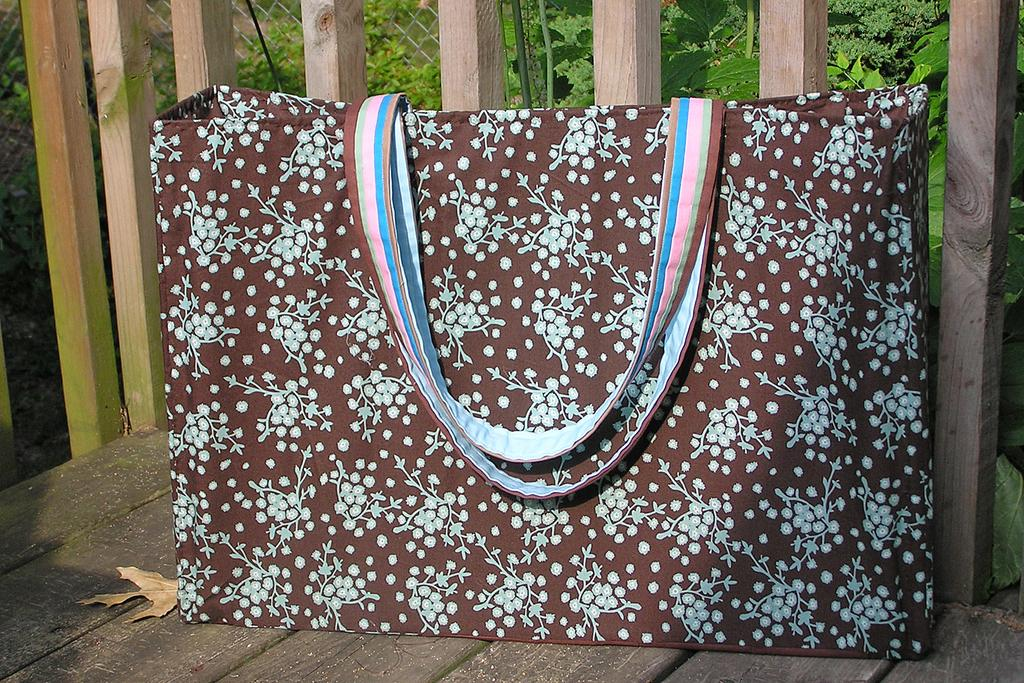What is the color of the bag in the image? The bag in the image is brown and white in color. Where is the bag located in the image? The bag is placed on a chair in the image. What can be seen in the background of the image? In the background of the image, there are multi-color holding threads and trees. What type of wool is being used to create the dirt in the image? There is no wool or dirt present in the image; it features a brown and white color bag placed on a chair with multi-color holding threads and trees in the background. 